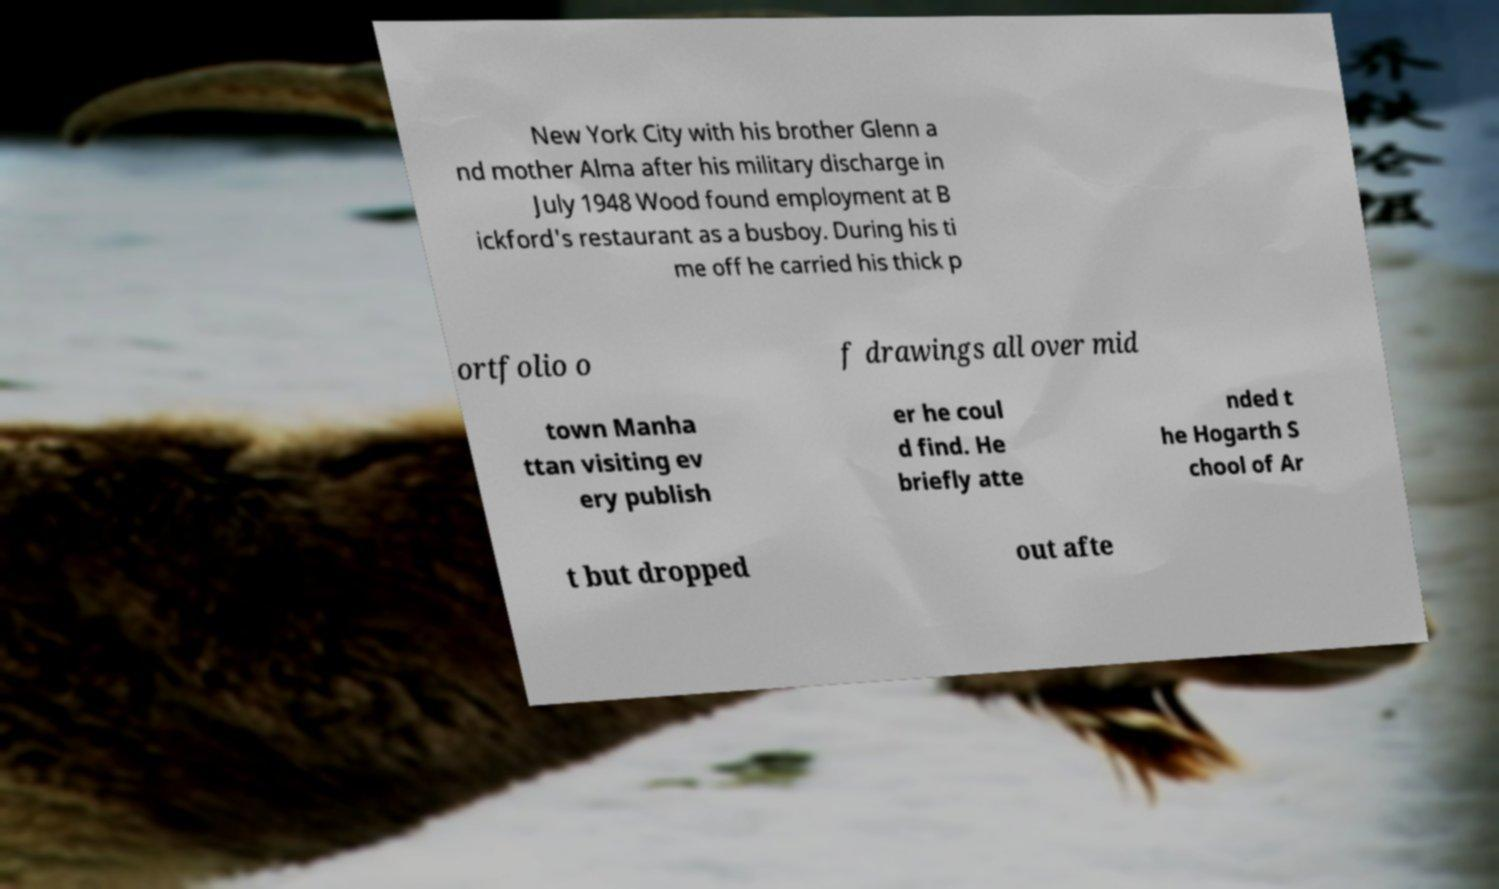There's text embedded in this image that I need extracted. Can you transcribe it verbatim? New York City with his brother Glenn a nd mother Alma after his military discharge in July 1948 Wood found employment at B ickford's restaurant as a busboy. During his ti me off he carried his thick p ortfolio o f drawings all over mid town Manha ttan visiting ev ery publish er he coul d find. He briefly atte nded t he Hogarth S chool of Ar t but dropped out afte 